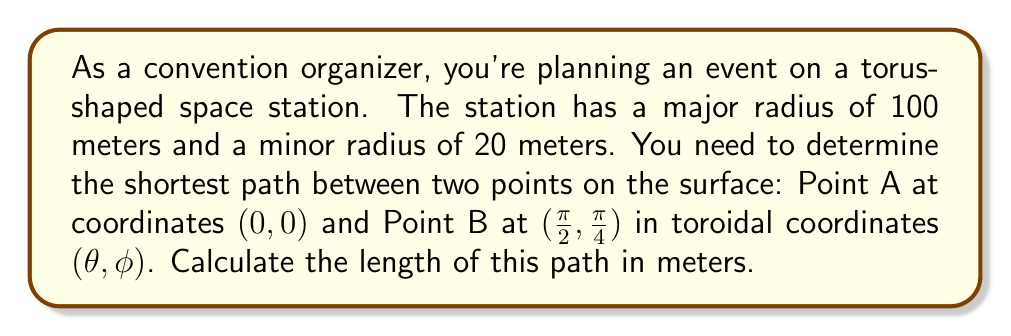Show me your answer to this math problem. To solve this problem, we'll follow these steps:

1) On a torus, the shortest path between two points is generally not a straight line but a geodesic. The formula for the distance along a geodesic on a torus is:

   $$d = \sqrt{(R\Delta\theta)^2 + (r\Delta\phi)^2}$$

   where $R$ is the major radius, $r$ is the minor radius, $\Delta\theta$ is the difference in $\theta$ coordinates, and $\Delta\phi$ is the difference in $\phi$ coordinates.

2) Given:
   - Major radius $R = 100$ meters
   - Minor radius $r = 20$ meters
   - Point A: $(0, 0)$
   - Point B: $(\frac{\pi}{2}, \frac{\pi}{4})$

3) Calculate $\Delta\theta$ and $\Delta\phi$:
   $$\Delta\theta = \frac{\pi}{2} - 0 = \frac{\pi}{2}$$
   $$\Delta\phi = \frac{\pi}{4} - 0 = \frac{\pi}{4}$$

4) Substitute these values into the formula:

   $$d = \sqrt{(100 \cdot \frac{\pi}{2})^2 + (20 \cdot \frac{\pi}{4})^2}$$

5) Simplify:
   $$d = \sqrt{(50\pi)^2 + (5\pi)^2}$$
   $$d = \sqrt{2500\pi^2 + 25\pi^2}$$
   $$d = \sqrt{2525\pi^2}$$
   $$d = \pi\sqrt{2525}$$

6) Calculate the final value:
   $$d \approx 157.86 \text{ meters}$$
Answer: $\pi\sqrt{2525} \approx 157.86 \text{ meters}$ 